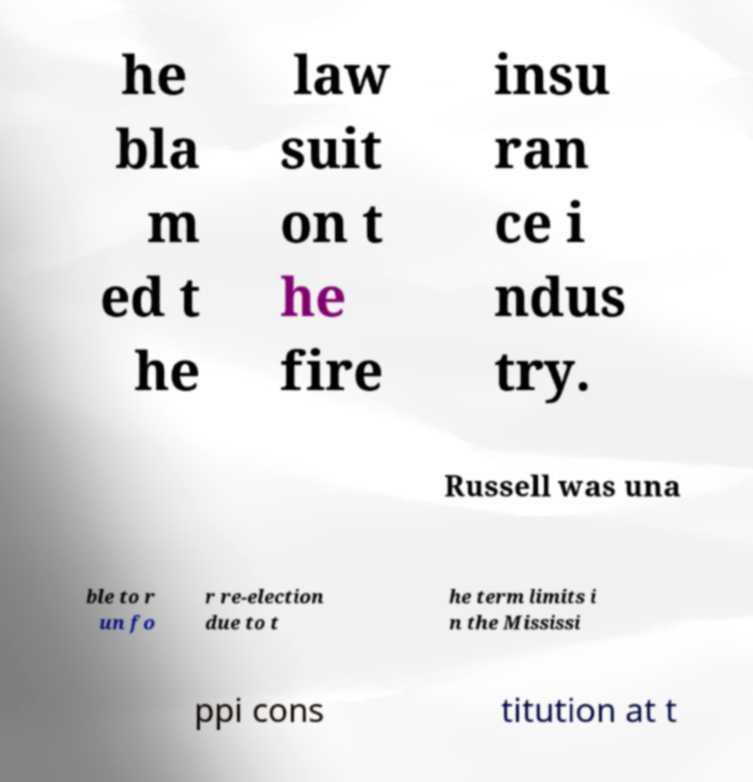Could you extract and type out the text from this image? he bla m ed t he law suit on t he fire insu ran ce i ndus try. Russell was una ble to r un fo r re-election due to t he term limits i n the Mississi ppi cons titution at t 